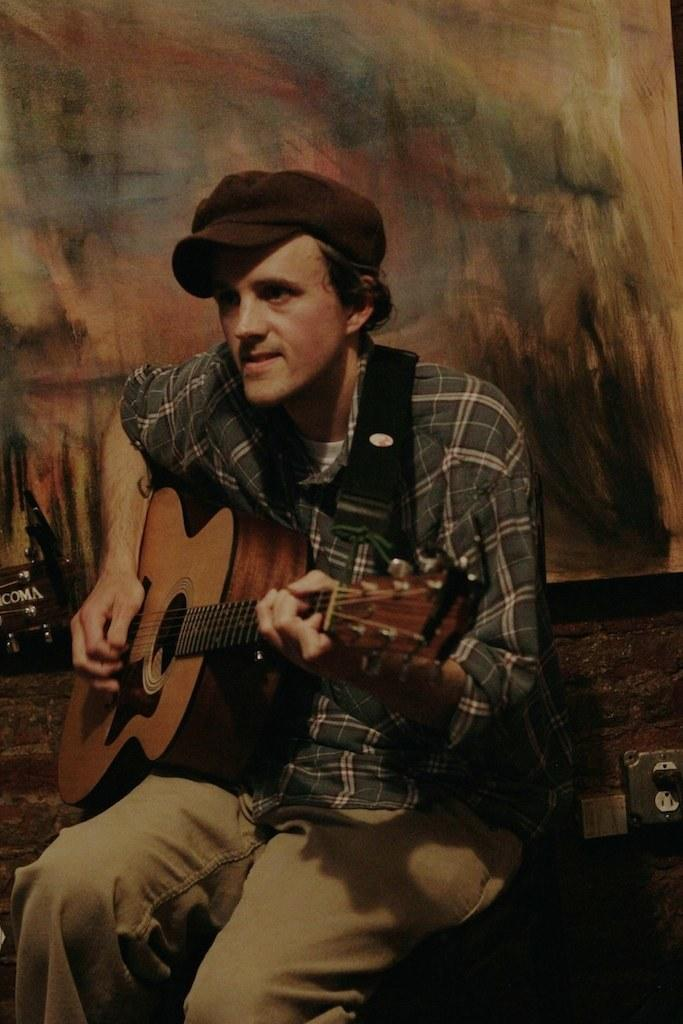What is the man in the image doing? The man is sitting on a bench and playing a guitar. How is the man holding the guitar? The man is holding the guitar while playing it. What type of clothing is the man wearing? The man is wearing a shirt, trousers, and a hat. What is located to the right of the man? There is a bag to the right of the man. What type of motion can be seen in the worm in the image? There is no worm present in the image, so no motion can be observed. 